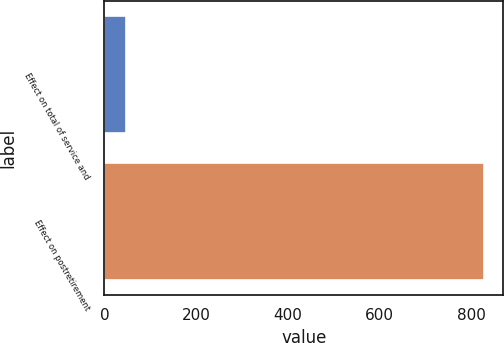<chart> <loc_0><loc_0><loc_500><loc_500><bar_chart><fcel>Effect on total of service and<fcel>Effect on postretirement<nl><fcel>46<fcel>827<nl></chart> 